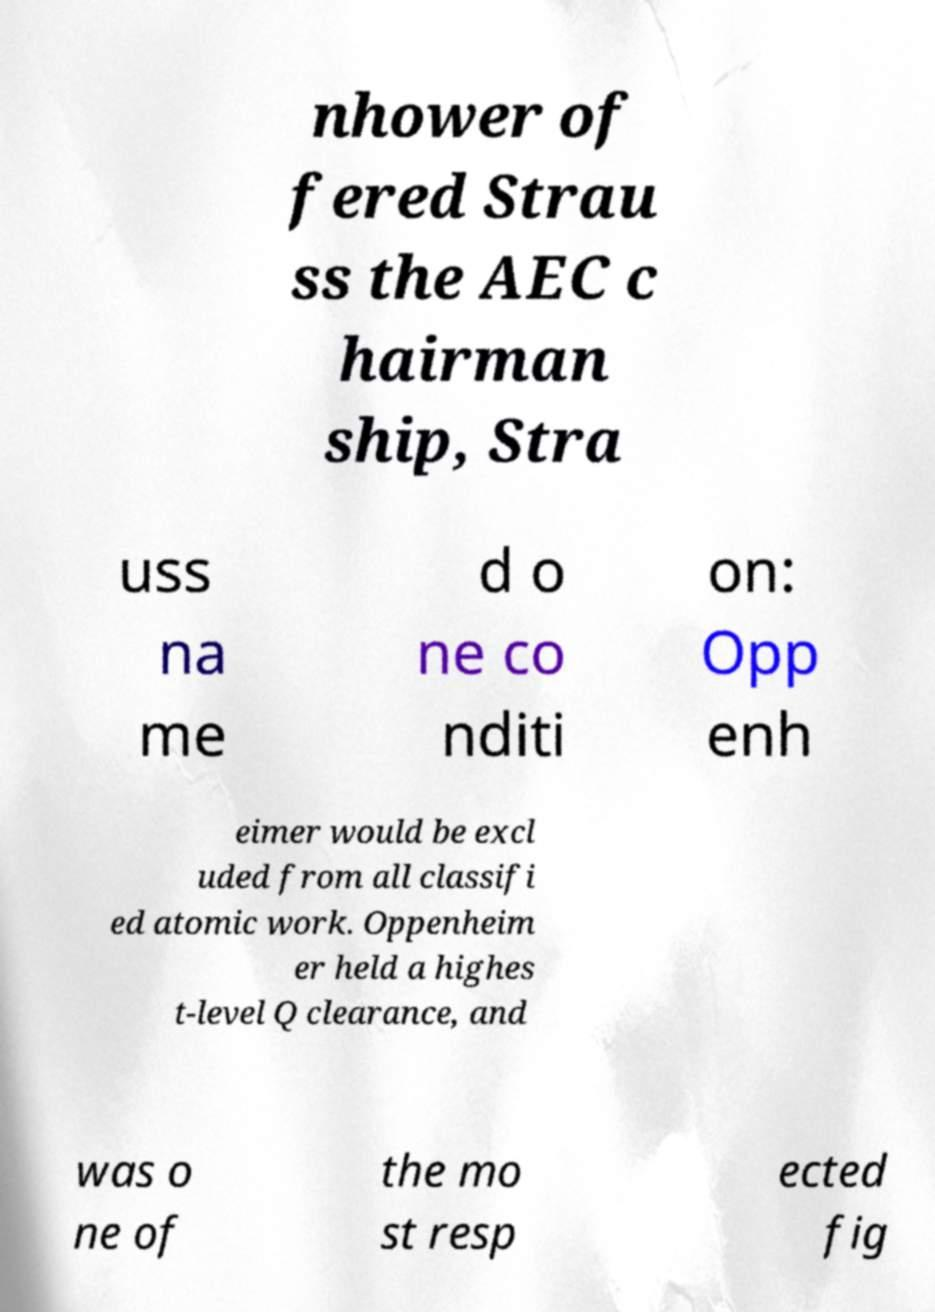Can you accurately transcribe the text from the provided image for me? nhower of fered Strau ss the AEC c hairman ship, Stra uss na me d o ne co nditi on: Opp enh eimer would be excl uded from all classifi ed atomic work. Oppenheim er held a highes t-level Q clearance, and was o ne of the mo st resp ected fig 